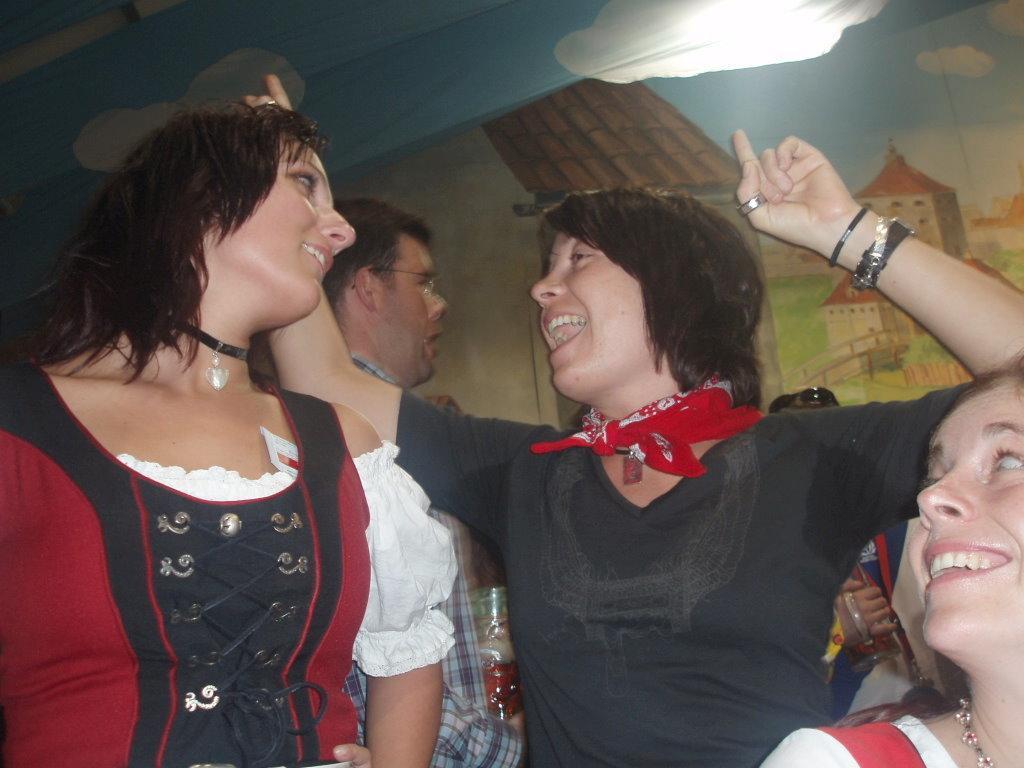Could you give a brief overview of what you see in this image? In this image there are some persons at bottom of this image and there is a wall in the background. 